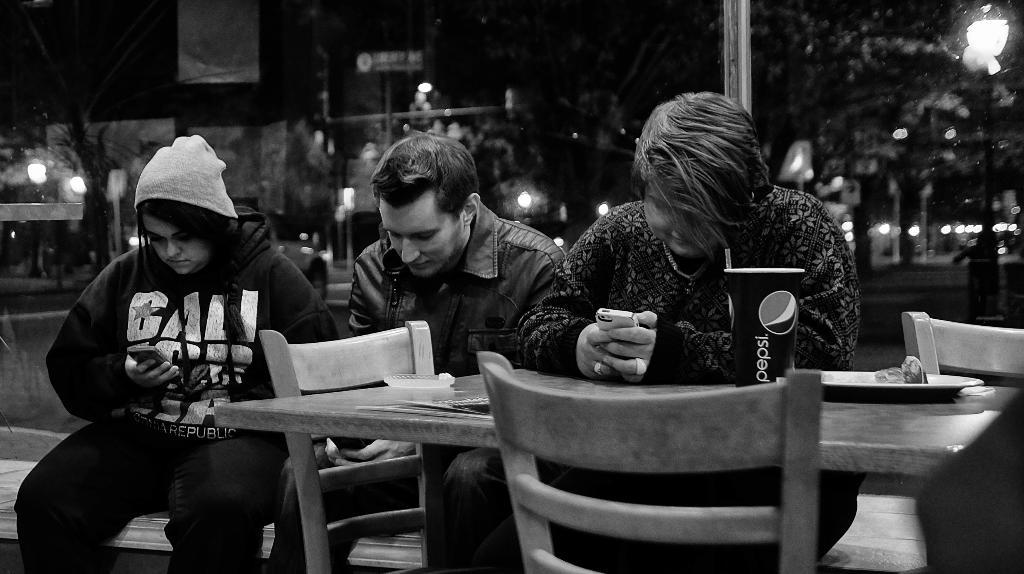How many people are sitting on the bench in the image? There are three people sitting on the bench in the image. What is located in the middle of the scene? There is a table in the middle of the scene. What items can be seen on the table? A plate and a cup are present on the table. What can be seen in the background of the image? There is a pole, a light, and trees visible in the background. Who is the owner of the plantation in the image? There is no plantation present in the image, so it is not possible to determine the owner. What is the value of the cup in the image? The value of the cup cannot be determined from the image alone, as it depends on various factors such as its material, age, and condition. 